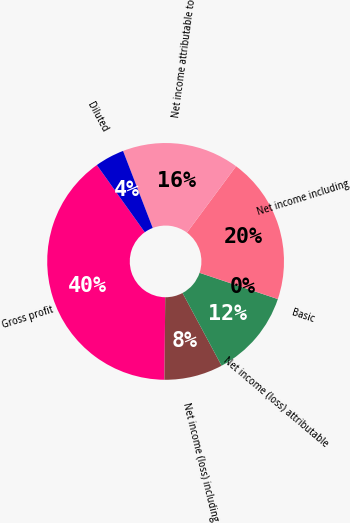<chart> <loc_0><loc_0><loc_500><loc_500><pie_chart><fcel>Gross profit<fcel>Net income (loss) including<fcel>Net income (loss) attributable<fcel>Basic<fcel>Net income including<fcel>Net income attributable to<fcel>Diluted<nl><fcel>39.98%<fcel>8.0%<fcel>12.0%<fcel>0.01%<fcel>20.0%<fcel>16.0%<fcel>4.01%<nl></chart> 